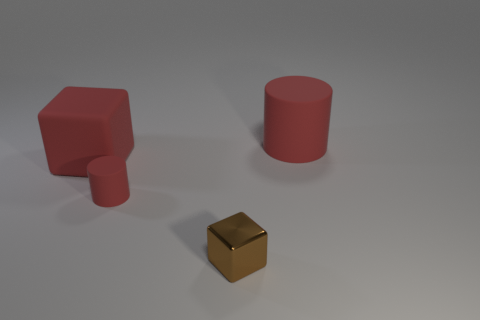What number of tiny red things have the same material as the brown cube? Upon reviewing the image, it appears that there are no tiny red things that match the material of the brown cube. The cube in the image has a distinct metallic sheen, whereas the red objects have a matte finish. Therefore, the number of tiny red things with the same material as the brown cube is zero. 